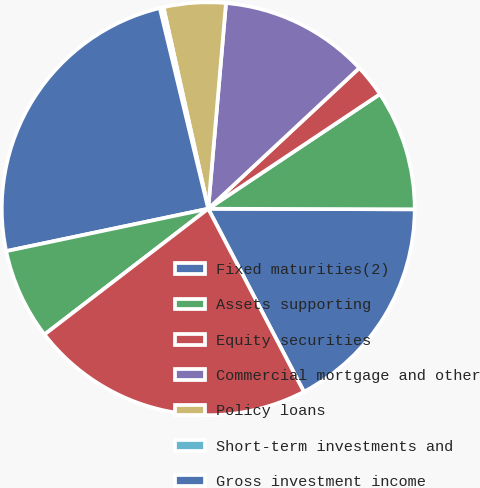Convert chart to OTSL. <chart><loc_0><loc_0><loc_500><loc_500><pie_chart><fcel>Fixed maturities(2)<fcel>Assets supporting<fcel>Equity securities<fcel>Commercial mortgage and other<fcel>Policy loans<fcel>Short-term investments and<fcel>Gross investment income<fcel>Investment expenses<fcel>Investment income after<nl><fcel>17.29%<fcel>9.41%<fcel>2.57%<fcel>11.69%<fcel>4.85%<fcel>0.29%<fcel>24.52%<fcel>7.13%<fcel>22.24%<nl></chart> 